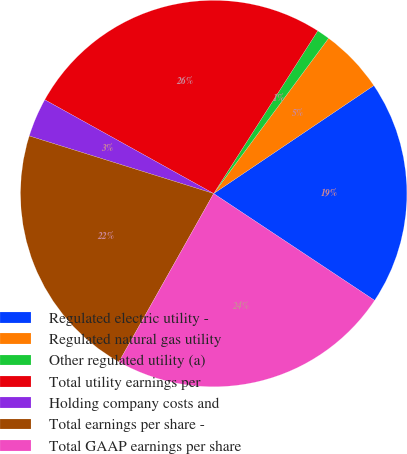<chart> <loc_0><loc_0><loc_500><loc_500><pie_chart><fcel>Regulated electric utility -<fcel>Regulated natural gas utility<fcel>Other regulated utility (a)<fcel>Total utility earnings per<fcel>Holding company costs and<fcel>Total earnings per share -<fcel>Total GAAP earnings per share<nl><fcel>18.77%<fcel>5.42%<fcel>1.08%<fcel>25.99%<fcel>3.25%<fcel>21.66%<fcel>23.83%<nl></chart> 